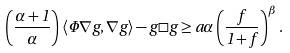Convert formula to latex. <formula><loc_0><loc_0><loc_500><loc_500>\left ( \frac { \alpha + 1 } { \alpha } \right ) \langle \Phi \nabla g , \nabla g \rangle - g \square g \geq a \alpha \left ( \frac { f } { 1 + f } \right ) ^ { \beta } .</formula> 